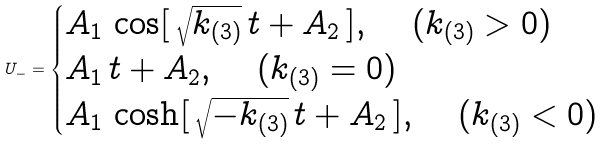<formula> <loc_0><loc_0><loc_500><loc_500>U _ { - } = \begin{cases} A _ { 1 } \, \cos [ \, \sqrt { k _ { ( 3 ) } } \, t + A _ { 2 } \, ] , \quad \, ( k _ { ( 3 ) } > 0 ) \\ A _ { 1 } \, t + A _ { 2 } , \quad \, ( k _ { ( 3 ) } = 0 ) \\ A _ { 1 } \, \cosh [ \, \sqrt { - k _ { ( 3 ) } } \, t + A _ { 2 } \, ] , \quad \, ( k _ { ( 3 ) } < 0 ) \end{cases}</formula> 